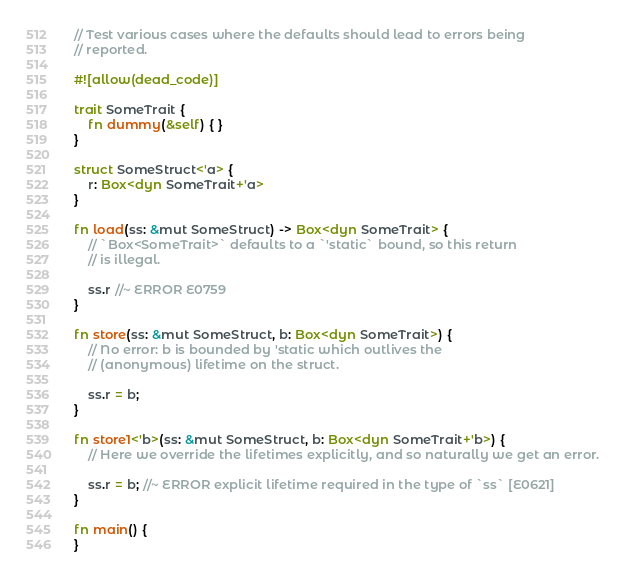Convert code to text. <code><loc_0><loc_0><loc_500><loc_500><_Rust_>// Test various cases where the defaults should lead to errors being
// reported.

#![allow(dead_code)]

trait SomeTrait {
    fn dummy(&self) { }
}

struct SomeStruct<'a> {
    r: Box<dyn SomeTrait+'a>
}

fn load(ss: &mut SomeStruct) -> Box<dyn SomeTrait> {
    // `Box<SomeTrait>` defaults to a `'static` bound, so this return
    // is illegal.

    ss.r //~ ERROR E0759
}

fn store(ss: &mut SomeStruct, b: Box<dyn SomeTrait>) {
    // No error: b is bounded by 'static which outlives the
    // (anonymous) lifetime on the struct.

    ss.r = b;
}

fn store1<'b>(ss: &mut SomeStruct, b: Box<dyn SomeTrait+'b>) {
    // Here we override the lifetimes explicitly, and so naturally we get an error.

    ss.r = b; //~ ERROR explicit lifetime required in the type of `ss` [E0621]
}

fn main() {
}
</code> 